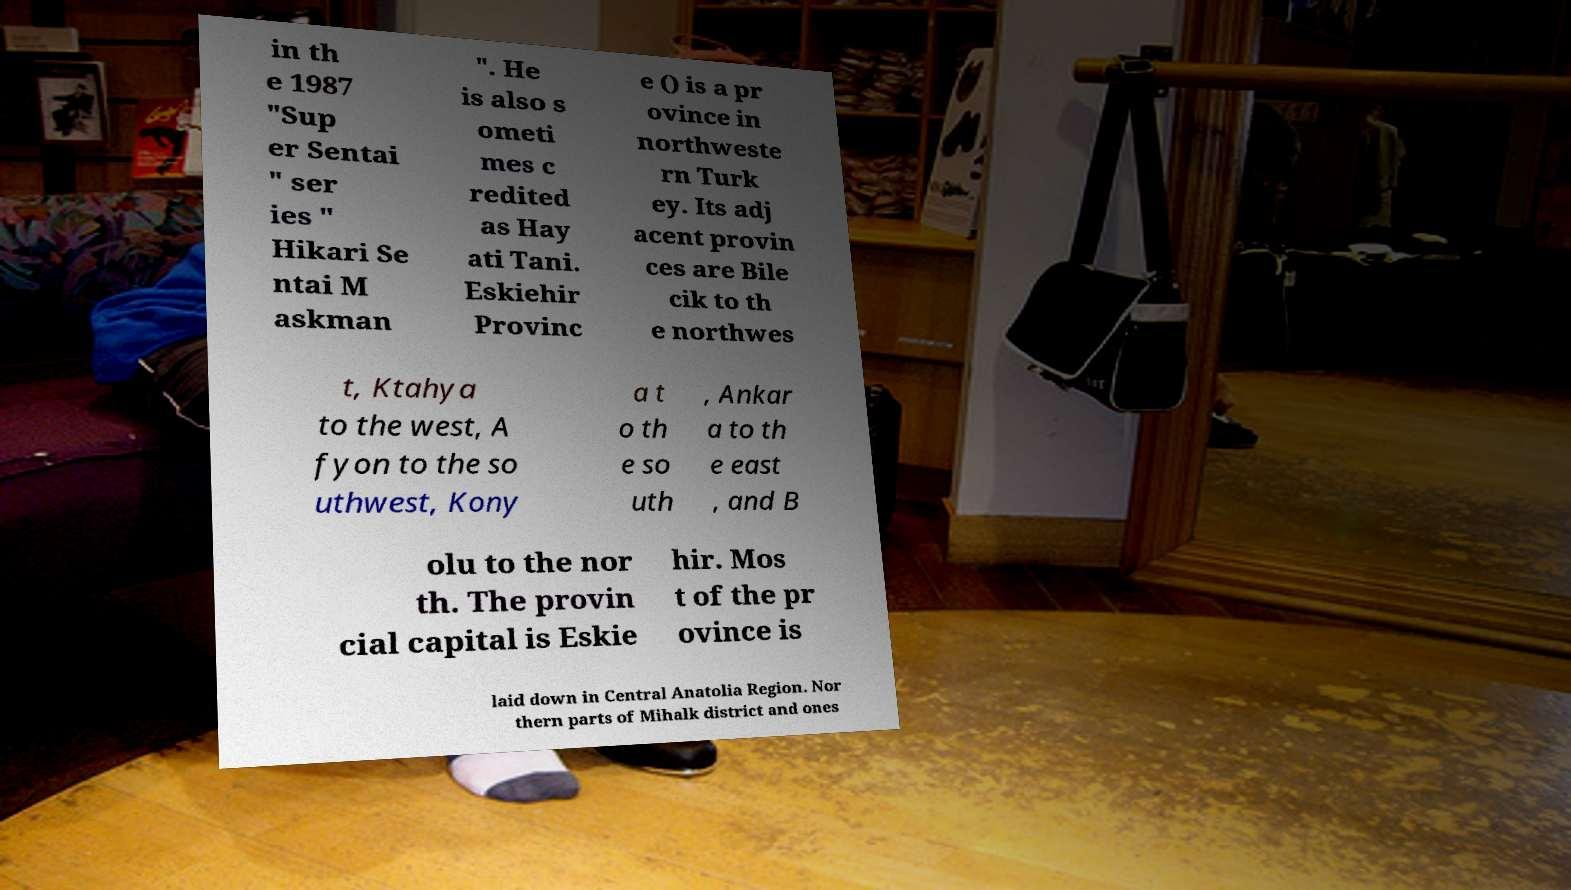I need the written content from this picture converted into text. Can you do that? in th e 1987 "Sup er Sentai " ser ies " Hikari Se ntai M askman ". He is also s ometi mes c redited as Hay ati Tani. Eskiehir Provinc e () is a pr ovince in northweste rn Turk ey. Its adj acent provin ces are Bile cik to th e northwes t, Ktahya to the west, A fyon to the so uthwest, Kony a t o th e so uth , Ankar a to th e east , and B olu to the nor th. The provin cial capital is Eskie hir. Mos t of the pr ovince is laid down in Central Anatolia Region. Nor thern parts of Mihalk district and ones 